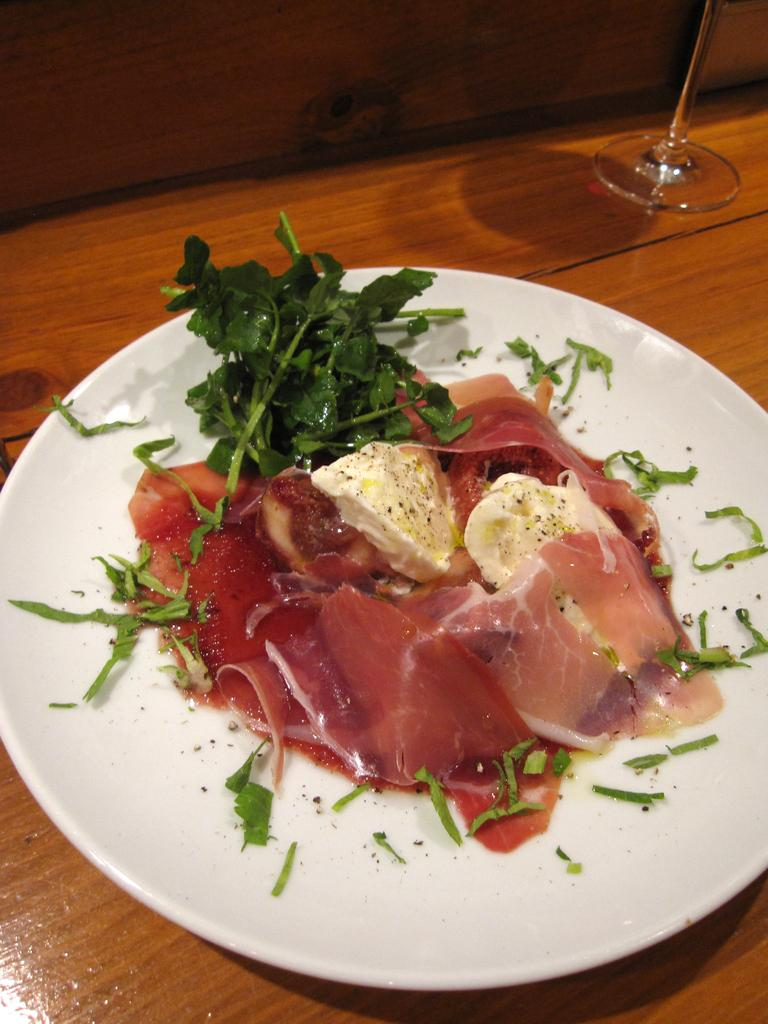What is located in the center of the image? There is a table in the center of the image. What is on the table in the image? There is a plate of food items and at least one glass on the table. Where is the nest located in the image? There is no nest present in the image. Can you tell me how many basketballs are on the table in the image? There are no basketballs present in the image. 